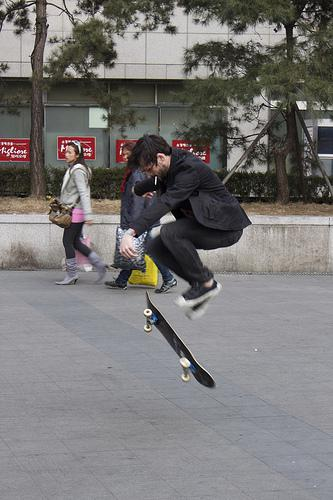Question: when was the photo taken?
Choices:
A. Nighttime.
B. Daytime.
C. Afternoon.
D. Noon.
Answer with the letter. Answer: B Question: what color are the signs?
Choices:
A. Teal.
B. Red.
C. Purple.
D. Neon.
Answer with the letter. Answer: B Question: what color writing is on the signs?
Choices:
A. Purple.
B. Neon.`.
C. White.
D. Tangerine.
Answer with the letter. Answer: C Question: what is the person in the air doing?
Choices:
A. Flying.
B. Jumping.
C. Skateboarding.
D. Bouncing.
Answer with the letter. Answer: C 